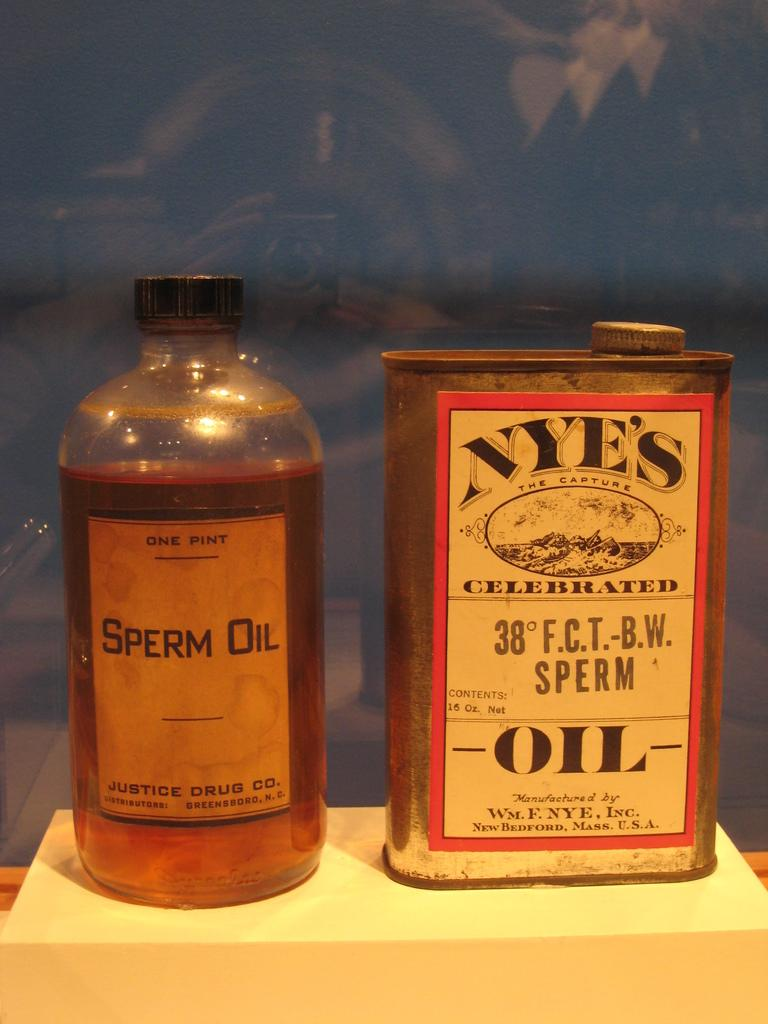<image>
Summarize the visual content of the image. A bottle of sperm oil next to a can of Nye's Oil. 